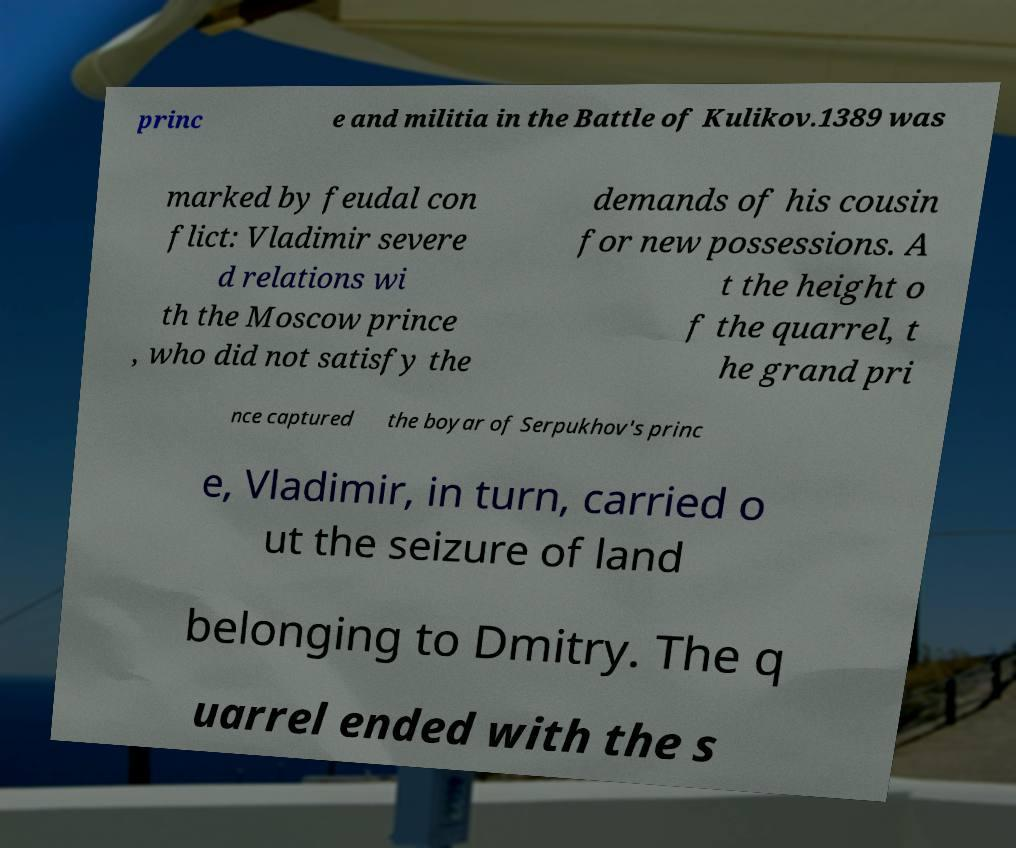Can you accurately transcribe the text from the provided image for me? princ e and militia in the Battle of Kulikov.1389 was marked by feudal con flict: Vladimir severe d relations wi th the Moscow prince , who did not satisfy the demands of his cousin for new possessions. A t the height o f the quarrel, t he grand pri nce captured the boyar of Serpukhov's princ e, Vladimir, in turn, carried o ut the seizure of land belonging to Dmitry. The q uarrel ended with the s 